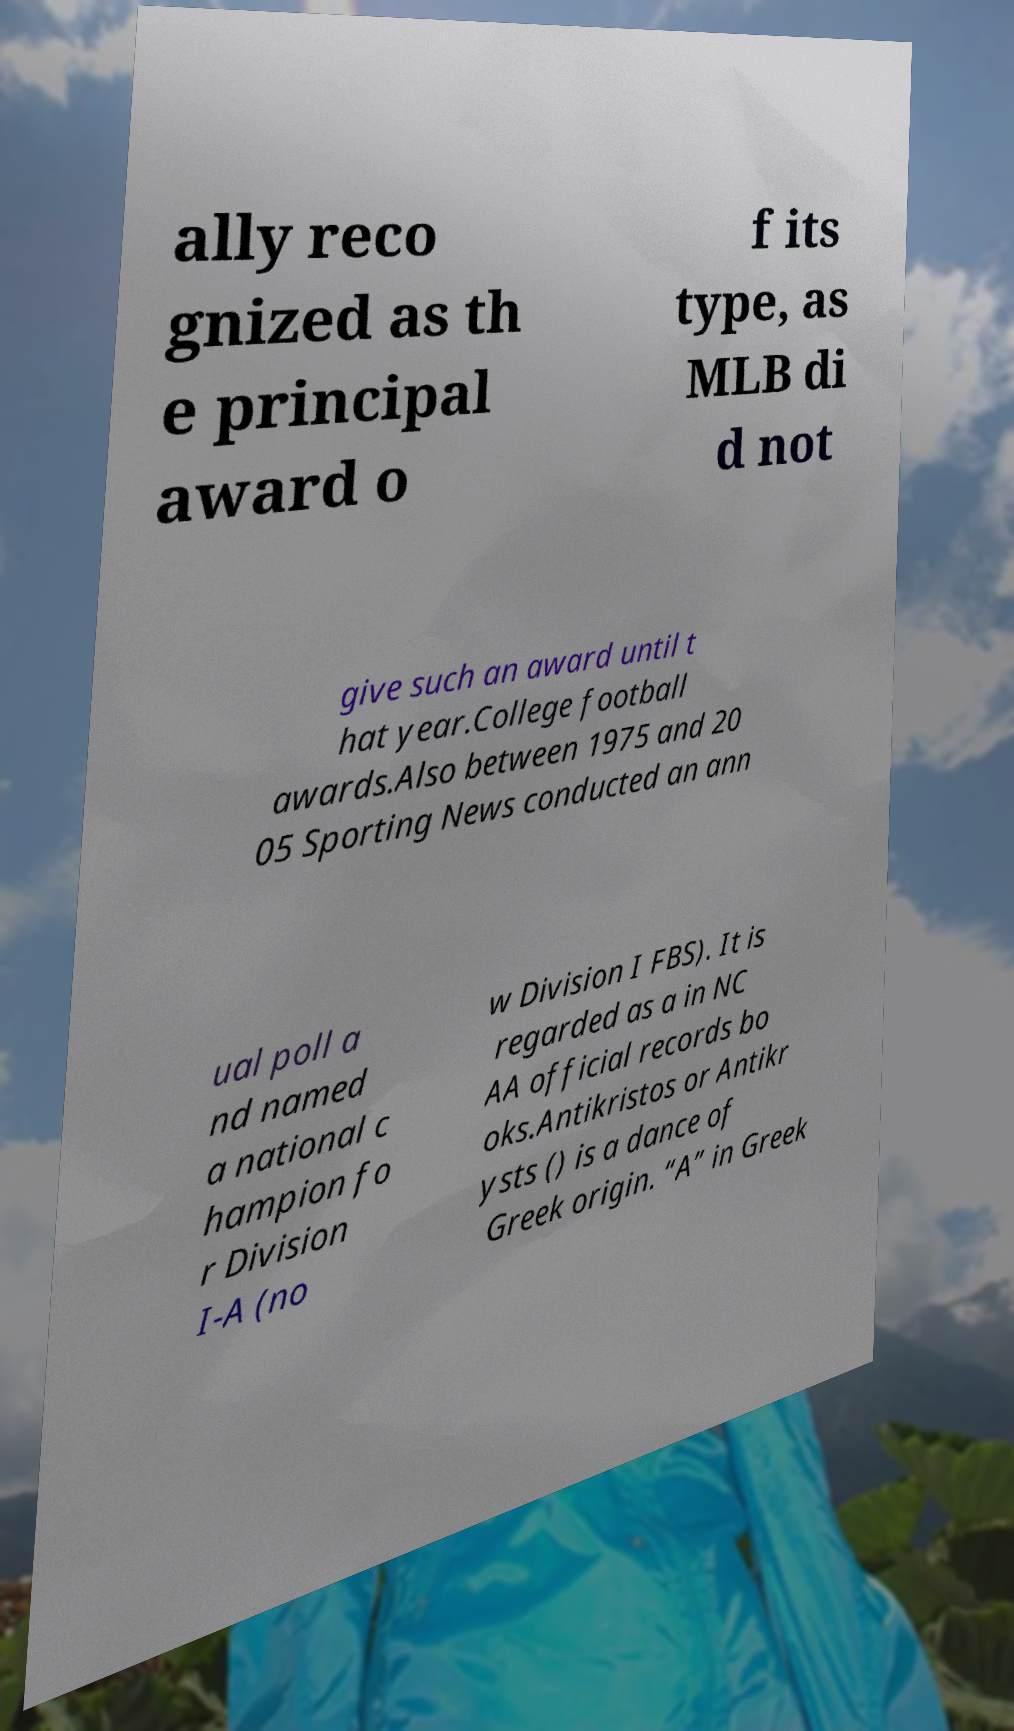Please read and relay the text visible in this image. What does it say? ally reco gnized as th e principal award o f its type, as MLB di d not give such an award until t hat year.College football awards.Also between 1975 and 20 05 Sporting News conducted an ann ual poll a nd named a national c hampion fo r Division I-A (no w Division I FBS). It is regarded as a in NC AA official records bo oks.Antikristos or Antikr ysts () is a dance of Greek origin. “A” in Greek 